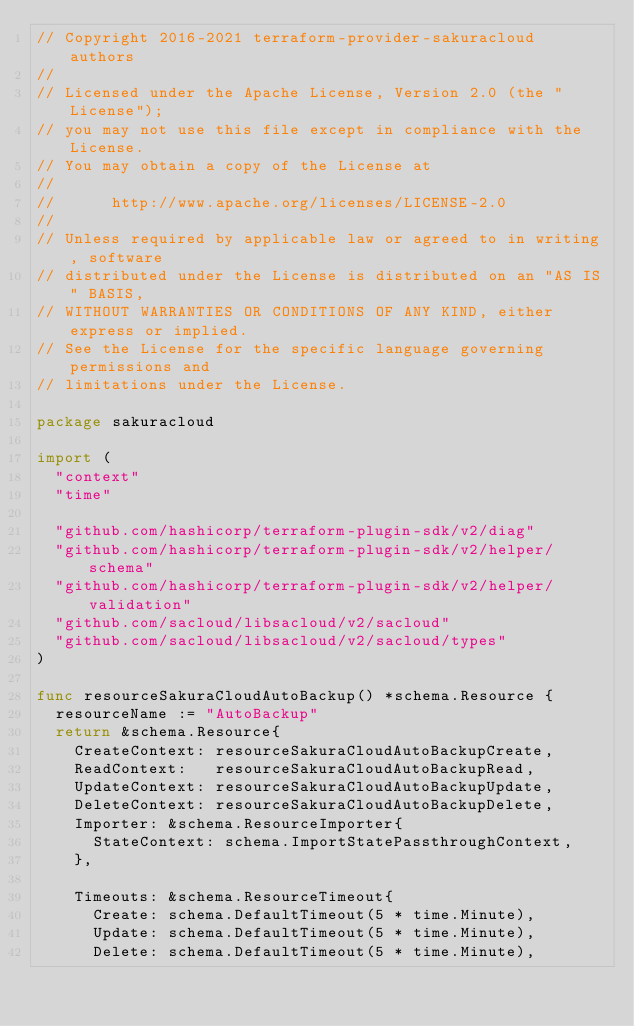<code> <loc_0><loc_0><loc_500><loc_500><_Go_>// Copyright 2016-2021 terraform-provider-sakuracloud authors
//
// Licensed under the Apache License, Version 2.0 (the "License");
// you may not use this file except in compliance with the License.
// You may obtain a copy of the License at
//
//      http://www.apache.org/licenses/LICENSE-2.0
//
// Unless required by applicable law or agreed to in writing, software
// distributed under the License is distributed on an "AS IS" BASIS,
// WITHOUT WARRANTIES OR CONDITIONS OF ANY KIND, either express or implied.
// See the License for the specific language governing permissions and
// limitations under the License.

package sakuracloud

import (
	"context"
	"time"

	"github.com/hashicorp/terraform-plugin-sdk/v2/diag"
	"github.com/hashicorp/terraform-plugin-sdk/v2/helper/schema"
	"github.com/hashicorp/terraform-plugin-sdk/v2/helper/validation"
	"github.com/sacloud/libsacloud/v2/sacloud"
	"github.com/sacloud/libsacloud/v2/sacloud/types"
)

func resourceSakuraCloudAutoBackup() *schema.Resource {
	resourceName := "AutoBackup"
	return &schema.Resource{
		CreateContext: resourceSakuraCloudAutoBackupCreate,
		ReadContext:   resourceSakuraCloudAutoBackupRead,
		UpdateContext: resourceSakuraCloudAutoBackupUpdate,
		DeleteContext: resourceSakuraCloudAutoBackupDelete,
		Importer: &schema.ResourceImporter{
			StateContext: schema.ImportStatePassthroughContext,
		},

		Timeouts: &schema.ResourceTimeout{
			Create: schema.DefaultTimeout(5 * time.Minute),
			Update: schema.DefaultTimeout(5 * time.Minute),
			Delete: schema.DefaultTimeout(5 * time.Minute),</code> 